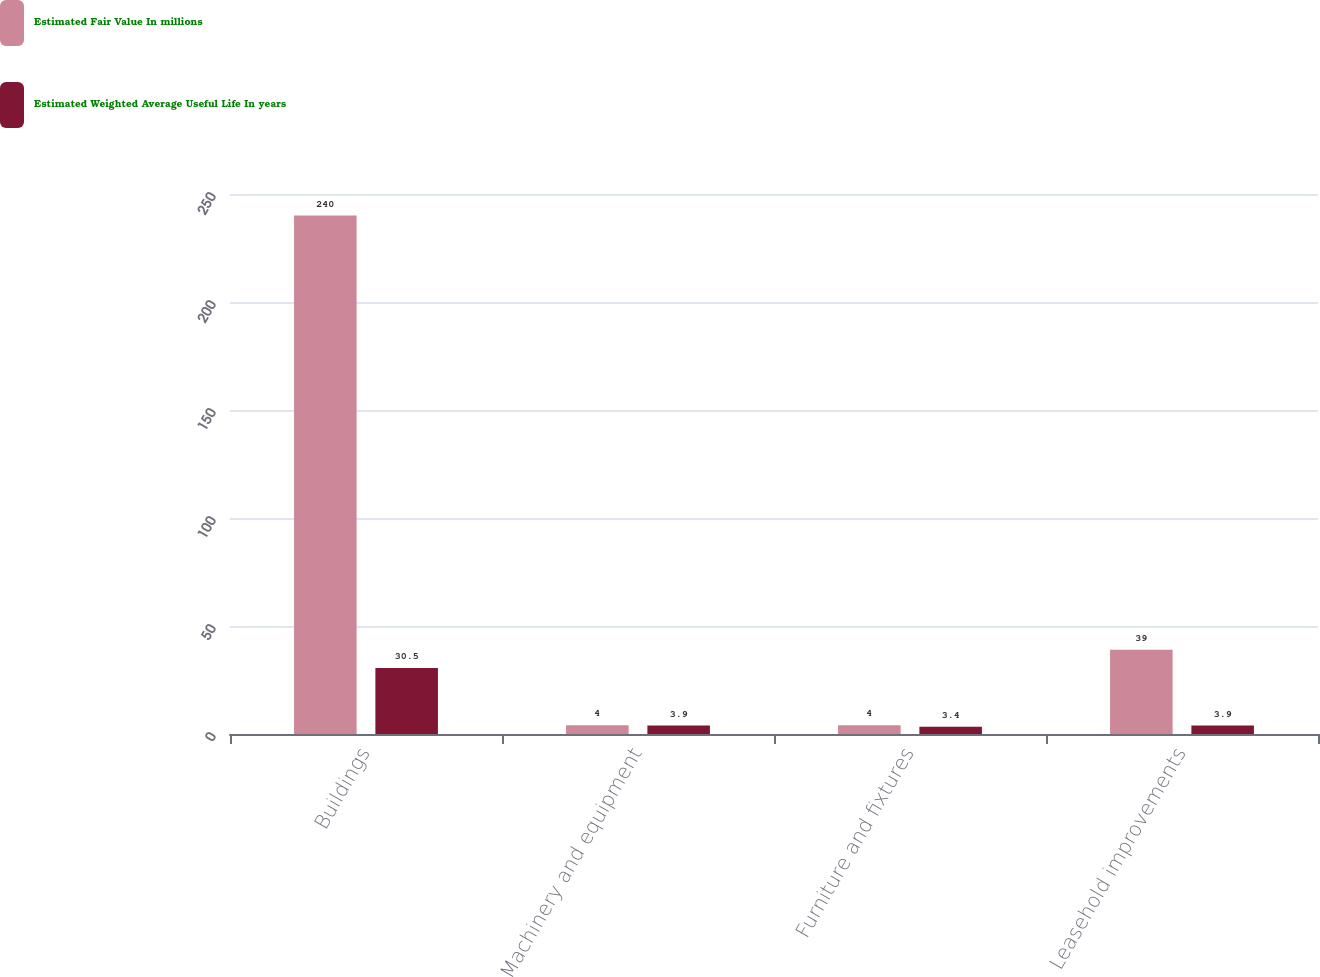Convert chart to OTSL. <chart><loc_0><loc_0><loc_500><loc_500><stacked_bar_chart><ecel><fcel>Buildings<fcel>Machinery and equipment<fcel>Furniture and fixtures<fcel>Leasehold improvements<nl><fcel>Estimated Fair Value In millions<fcel>240<fcel>4<fcel>4<fcel>39<nl><fcel>Estimated Weighted Average Useful Life In years<fcel>30.5<fcel>3.9<fcel>3.4<fcel>3.9<nl></chart> 